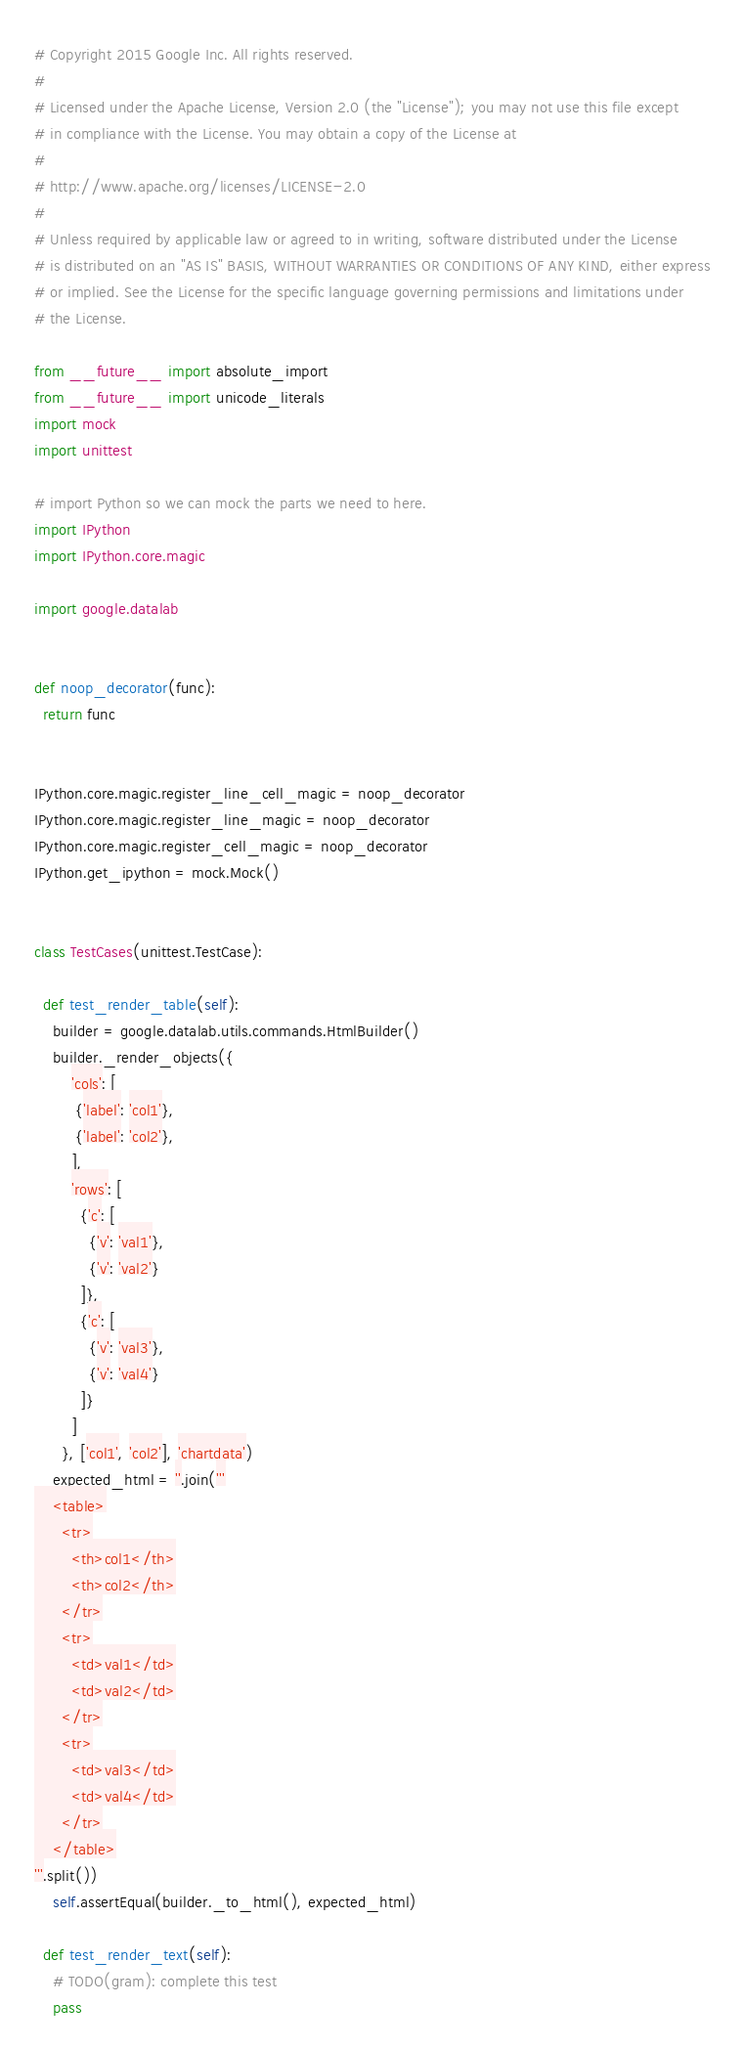<code> <loc_0><loc_0><loc_500><loc_500><_Python_># Copyright 2015 Google Inc. All rights reserved.
#
# Licensed under the Apache License, Version 2.0 (the "License"); you may not use this file except
# in compliance with the License. You may obtain a copy of the License at
#
# http://www.apache.org/licenses/LICENSE-2.0
#
# Unless required by applicable law or agreed to in writing, software distributed under the License
# is distributed on an "AS IS" BASIS, WITHOUT WARRANTIES OR CONDITIONS OF ANY KIND, either express
# or implied. See the License for the specific language governing permissions and limitations under
# the License.

from __future__ import absolute_import
from __future__ import unicode_literals
import mock
import unittest

# import Python so we can mock the parts we need to here.
import IPython
import IPython.core.magic

import google.datalab


def noop_decorator(func):
  return func


IPython.core.magic.register_line_cell_magic = noop_decorator
IPython.core.magic.register_line_magic = noop_decorator
IPython.core.magic.register_cell_magic = noop_decorator
IPython.get_ipython = mock.Mock()


class TestCases(unittest.TestCase):

  def test_render_table(self):
    builder = google.datalab.utils.commands.HtmlBuilder()
    builder._render_objects({
        'cols': [
         {'label': 'col1'},
         {'label': 'col2'},
        ],
        'rows': [
          {'c': [
            {'v': 'val1'},
            {'v': 'val2'}
          ]},
          {'c': [
            {'v': 'val3'},
            {'v': 'val4'}
          ]}
        ]
      }, ['col1', 'col2'], 'chartdata')
    expected_html = ''.join('''
    <table>
      <tr>
        <th>col1</th>
        <th>col2</th>
      </tr>
      <tr>
        <td>val1</td>
        <td>val2</td>
      </tr>
      <tr>
        <td>val3</td>
        <td>val4</td>
      </tr>
    </table>
'''.split())
    self.assertEqual(builder._to_html(), expected_html)

  def test_render_text(self):
    # TODO(gram): complete this test
    pass
</code> 